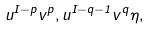Convert formula to latex. <formula><loc_0><loc_0><loc_500><loc_500>u ^ { I - p } v ^ { p } , u ^ { I - q - 1 } v ^ { q } \eta ,</formula> 